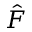<formula> <loc_0><loc_0><loc_500><loc_500>\hat { F }</formula> 